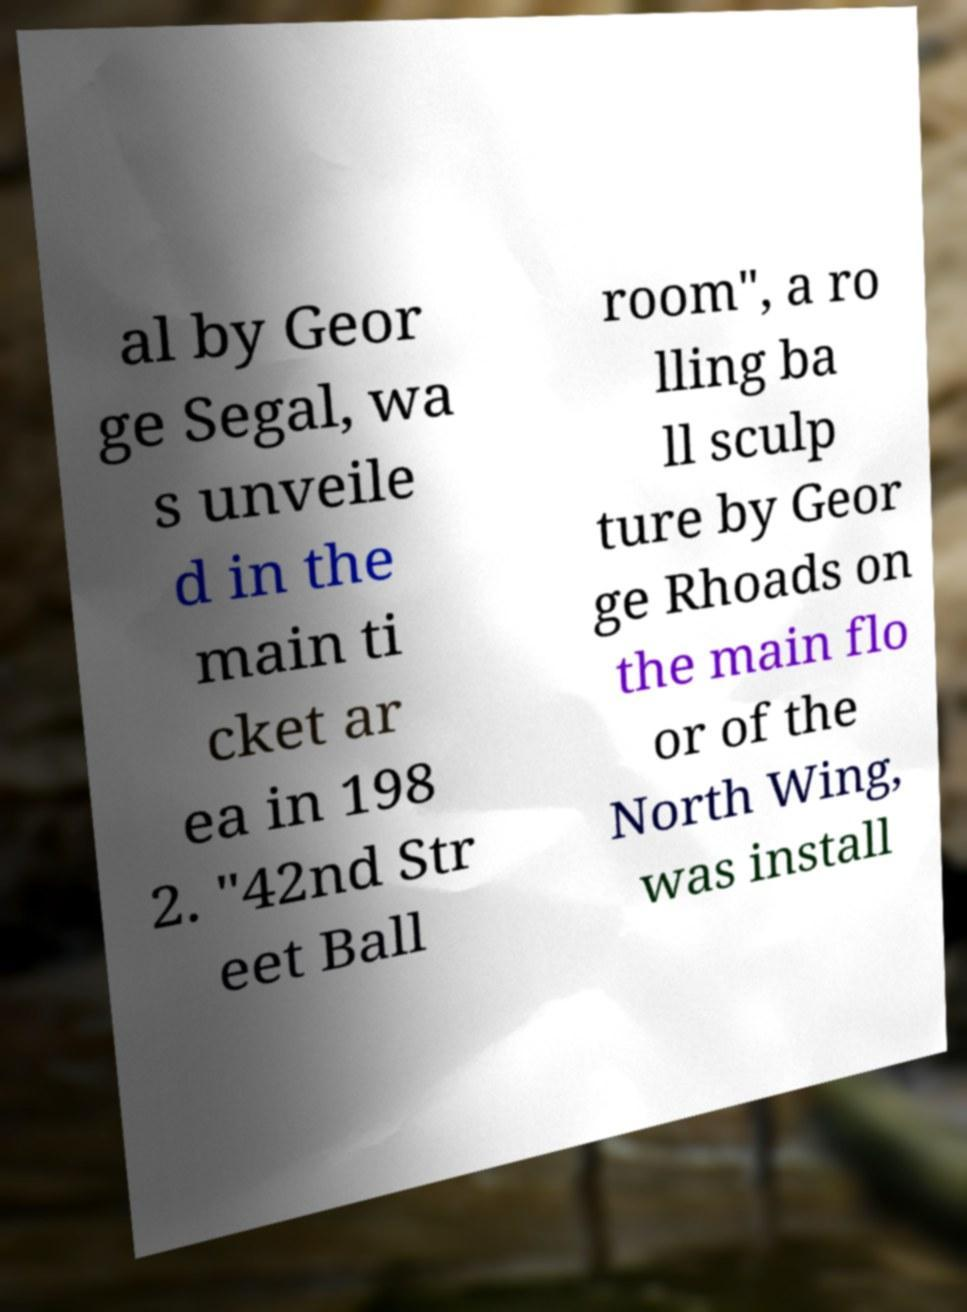Can you accurately transcribe the text from the provided image for me? al by Geor ge Segal, wa s unveile d in the main ti cket ar ea in 198 2. "42nd Str eet Ball room", a ro lling ba ll sculp ture by Geor ge Rhoads on the main flo or of the North Wing, was install 